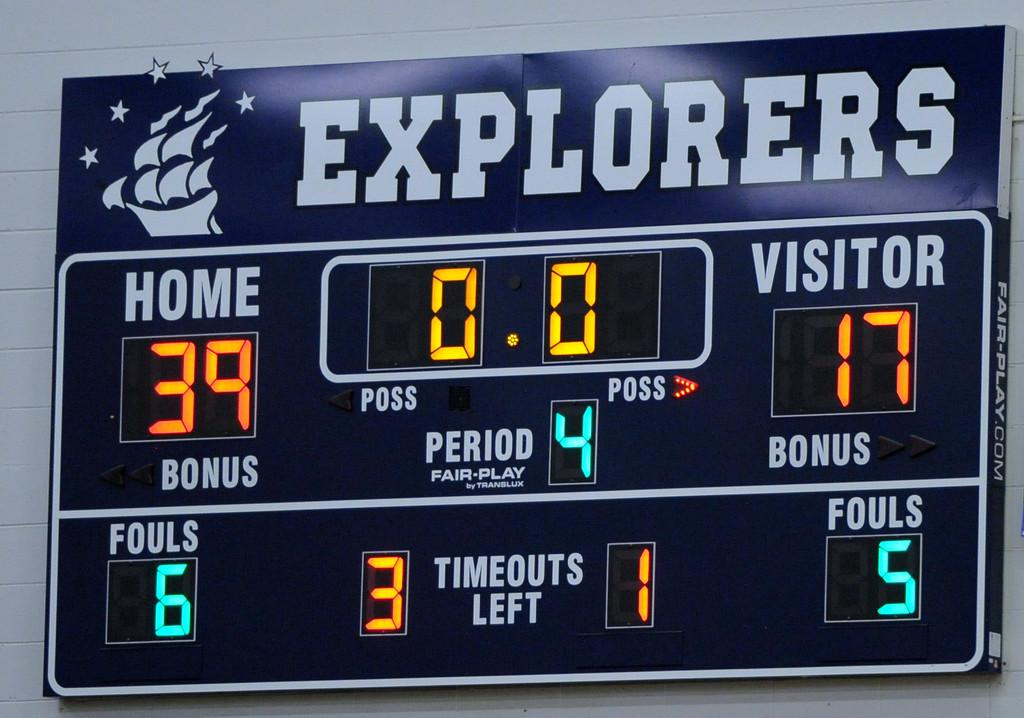<image>
Relay a brief, clear account of the picture shown. A scoreboard shows that the Explorers are winning 39 to 17. 